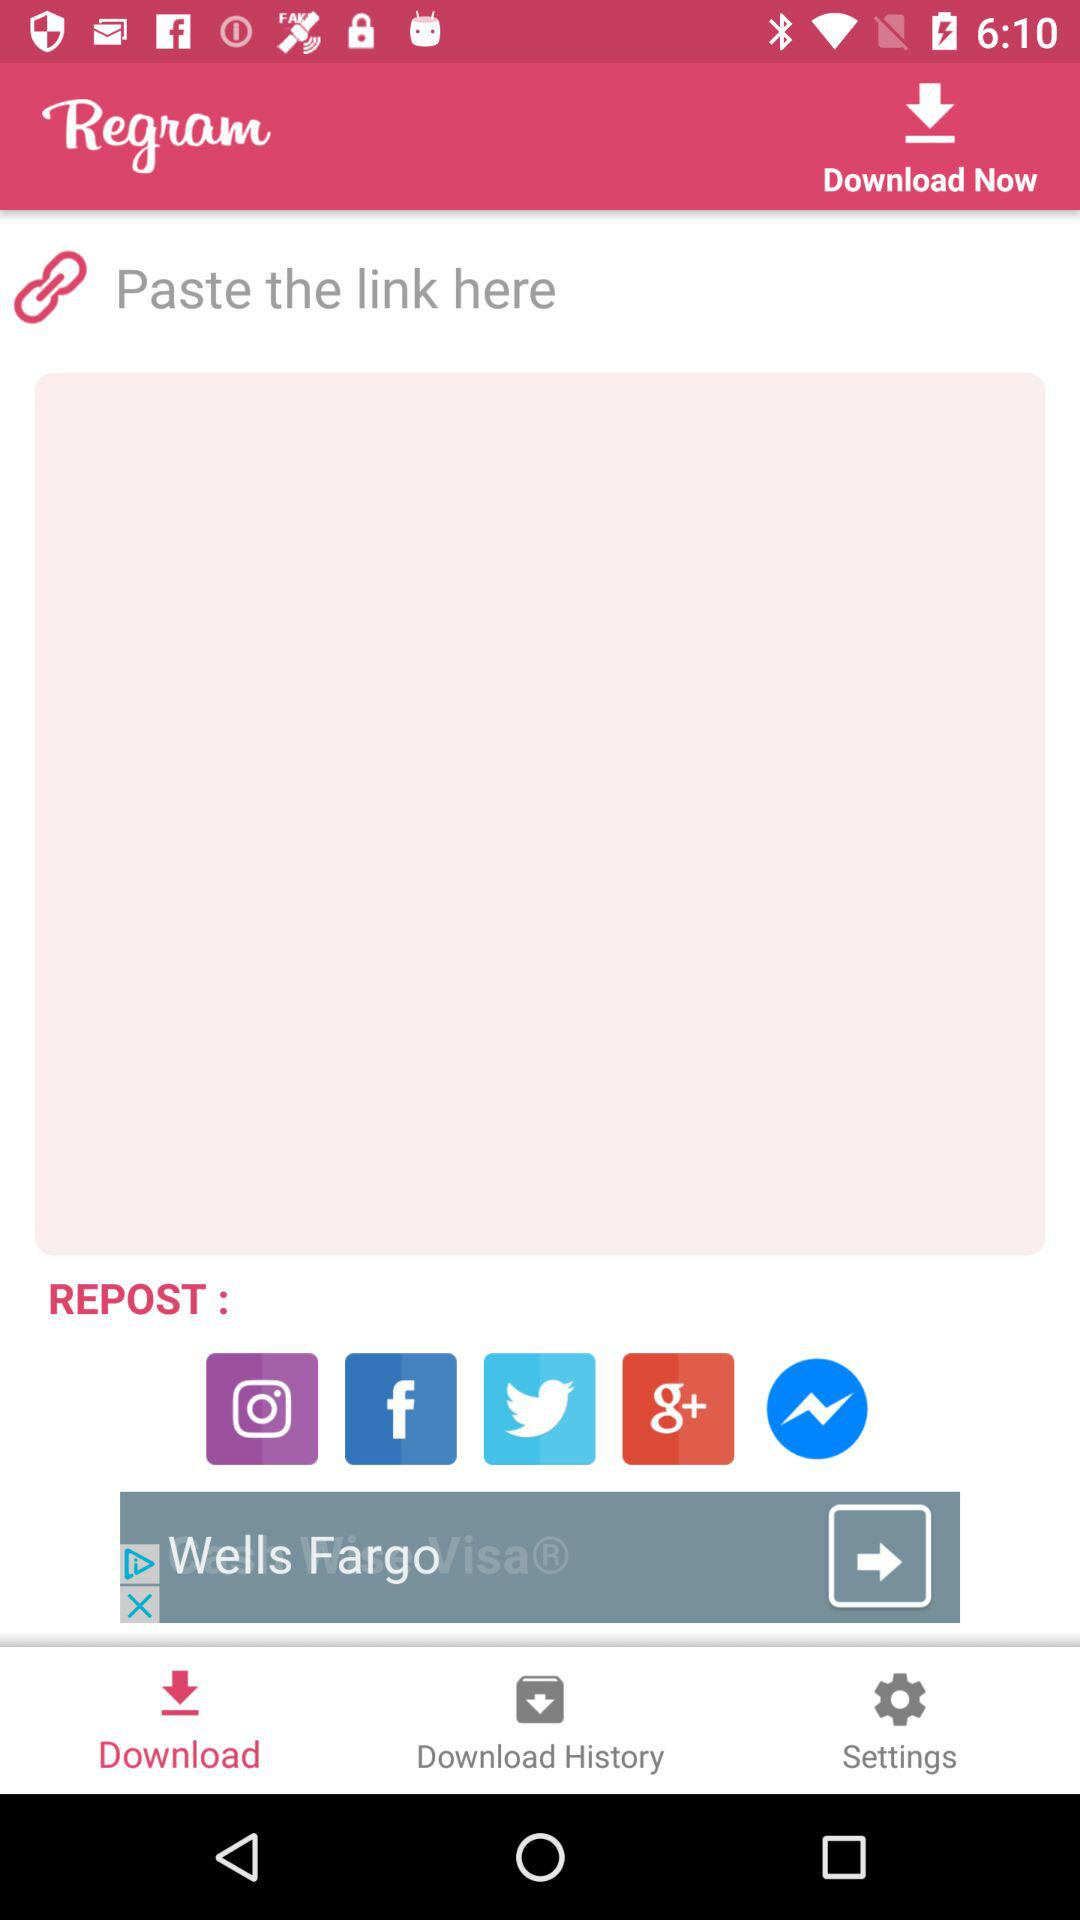Which tab is selected? The selected tab is "Download". 